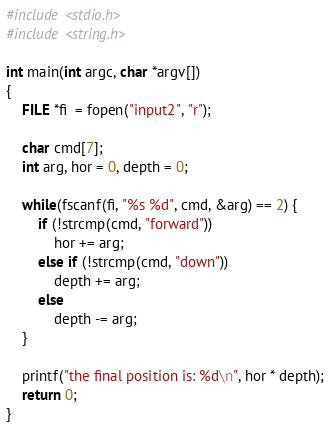<code> <loc_0><loc_0><loc_500><loc_500><_C_>#include <stdio.h>
#include <string.h>

int main(int argc, char *argv[])
{
    FILE *fi  = fopen("input2", "r");

    char cmd[7];
    int arg, hor = 0, depth = 0;

    while(fscanf(fi, "%s %d", cmd, &arg) == 2) {
        if (!strcmp(cmd, "forward"))
            hor += arg;
        else if (!strcmp(cmd, "down"))
            depth += arg;
        else
            depth -= arg;
    } 
    
    printf("the final position is: %d\n", hor * depth);
    return 0;
}
</code> 